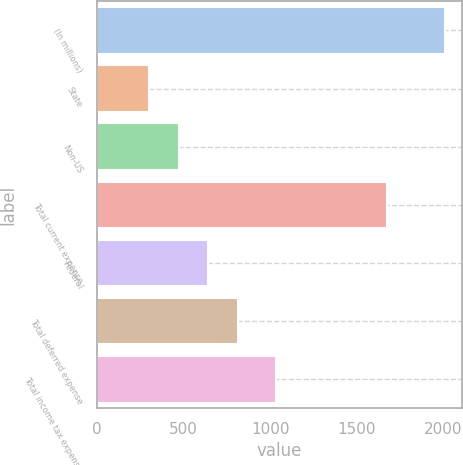Convert chart. <chart><loc_0><loc_0><loc_500><loc_500><bar_chart><fcel>(In millions)<fcel>State<fcel>Non-US<fcel>Total current expense<fcel>Federal<fcel>Total deferred expense<fcel>Total income tax expense<nl><fcel>2008<fcel>299<fcel>469.9<fcel>1673<fcel>640.8<fcel>811.7<fcel>1031<nl></chart> 